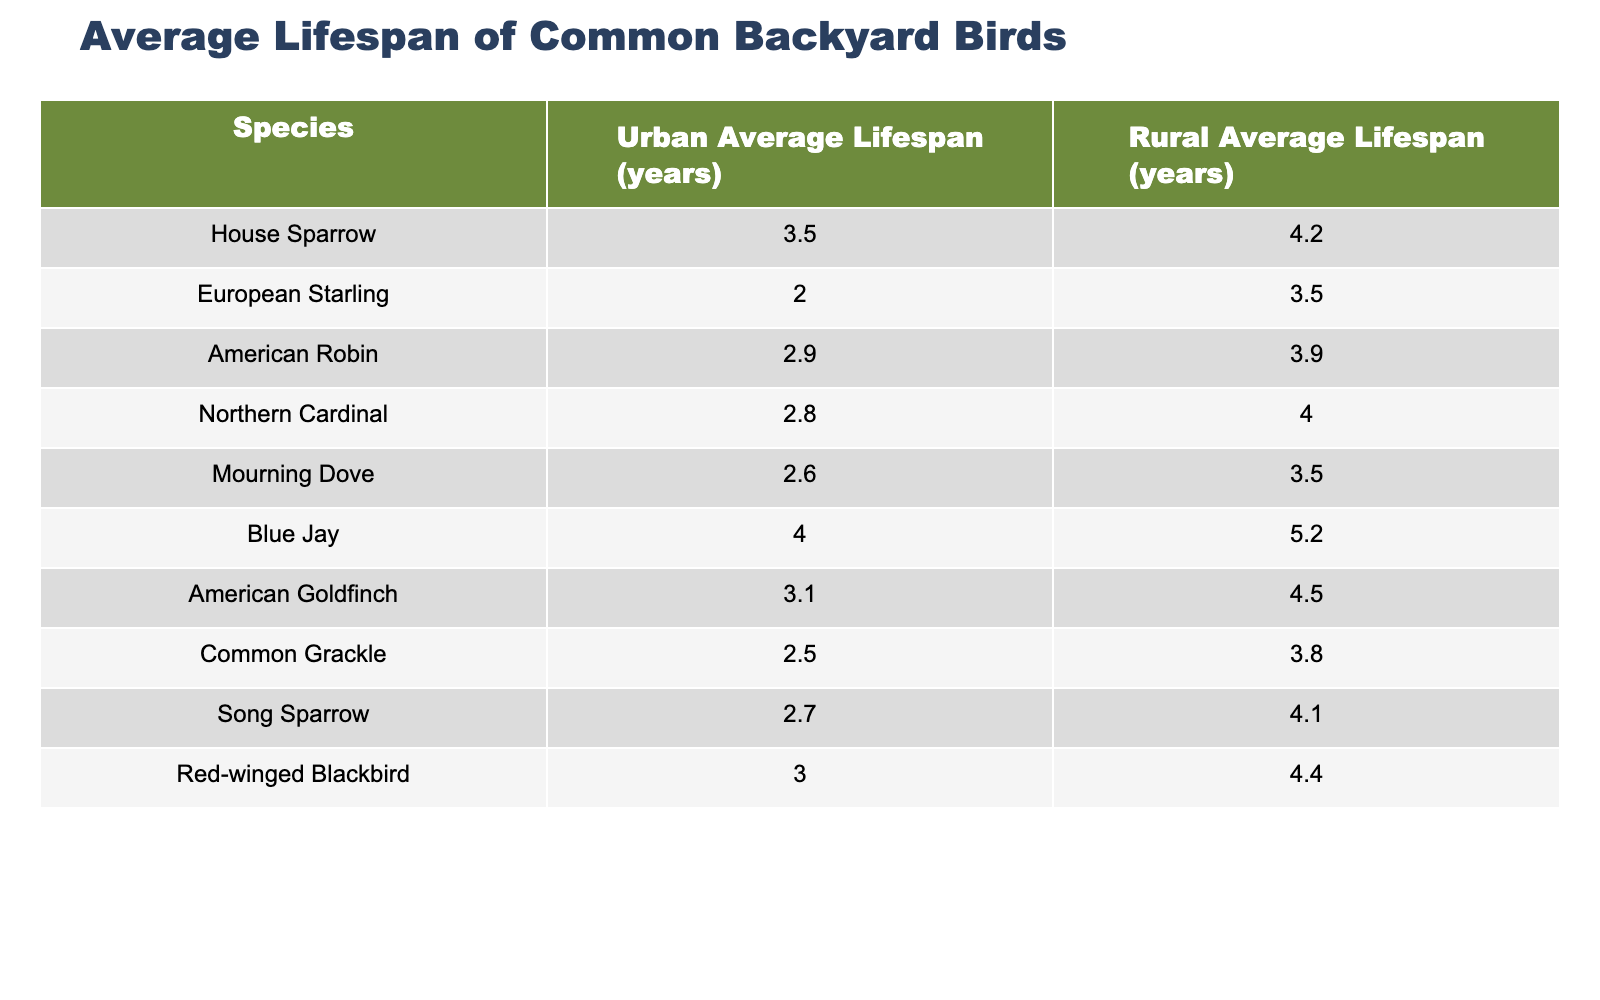What is the average lifespan of the House Sparrow in urban areas? Looking at the table, the column for "Urban Average Lifespan (years)" for the House Sparrow shows a value of 3.5 years.
Answer: 3.5 years Which bird has the highest average lifespan in rural areas? In the "Rural Average Lifespan (years)" column, the Blue Jay has the highest value of 5.2 years, which is more than the other species listed.
Answer: Blue Jay How much longer does the American Goldfinch live on average in rural areas compared to urban areas? The rural lifespan for the American Goldfinch is 4.5 years and the urban lifespan is 3.1 years. The difference is calculated as 4.5 - 3.1 = 1.4 years.
Answer: 1.4 years Is the average lifespan of the Mourning Dove longer in urban areas than the European Starling? The Urban Average Lifespan of the Mourning Dove is 2.6 years, while the European Starling is 2.0 years. Since 2.6 is greater than 2.0, it is true that the Mourning Dove lives longer on average in urban areas.
Answer: Yes What is the difference in average lifespan between the Red-winged Blackbird in urban and rural areas? The urban average lifespan for the Red-winged Blackbird is 3.0 years, and the rural average is 4.4 years. The difference is calculated as 4.4 - 3.0 = 1.4 years, meaning it lives longer in rural areas.
Answer: 1.4 years Which species has a longer lifespan in urban areas: the Northern Cardinal or the American Robin? The urban lifespan for the Northern Cardinal is 2.8 years, while the American Robin's urban lifespan is 2.9 years. Since 2.9 is greater than 2.8, the American Robin lives longer on average in urban areas.
Answer: American Robin What is the average urban lifespan of the Song Sparrow? Referring to the table, the Urban Average Lifespan for the Song Sparrow is 2.7 years.
Answer: 2.7 years How many species have an urban average lifespan of less than three years? By examining the "Urban Average Lifespan (years)" column, the species with lifespans less than 3 years are the European Starling (2.0), Mourning Dove (2.6), Common Grackle (2.5), and Song Sparrow (2.7). This totals four species.
Answer: 4 species 